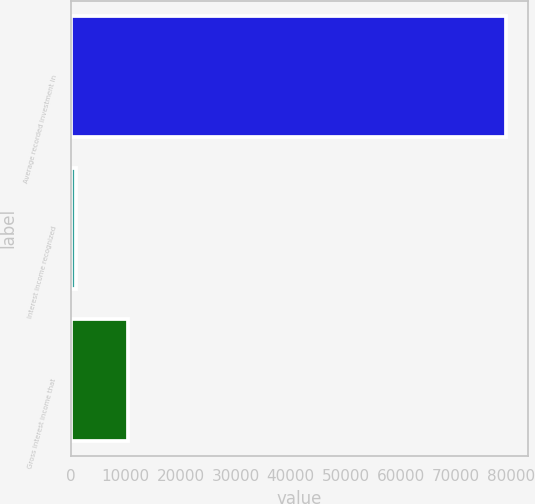Convert chart. <chart><loc_0><loc_0><loc_500><loc_500><bar_chart><fcel>Average recorded investment in<fcel>Interest income recognized<fcel>Gross interest income that<nl><fcel>79165<fcel>937<fcel>10454<nl></chart> 